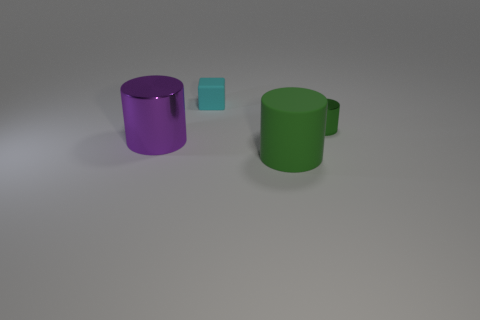Is the small metal cylinder the same color as the rubber cylinder?
Give a very brief answer. Yes. Are the green cylinder that is in front of the small shiny object and the tiny object that is to the left of the large matte cylinder made of the same material?
Provide a succinct answer. Yes. What material is the green cylinder that is left of the shiny cylinder that is to the right of the tiny cyan thing made of?
Provide a succinct answer. Rubber. There is a cylinder in front of the big cylinder that is to the left of the green thing that is on the left side of the tiny green metal cylinder; what size is it?
Your response must be concise. Large. Is the cyan rubber block the same size as the green metal cylinder?
Keep it short and to the point. Yes. Is the shape of the big thing behind the large rubber cylinder the same as the green object in front of the large shiny thing?
Offer a terse response. Yes. There is a large cylinder on the left side of the small cyan thing; is there a big thing on the right side of it?
Your answer should be very brief. Yes. Are there any cylinders?
Give a very brief answer. Yes. How many cyan matte things have the same size as the green metal cylinder?
Give a very brief answer. 1. What number of things are both behind the green matte cylinder and in front of the cyan matte thing?
Give a very brief answer. 2. 